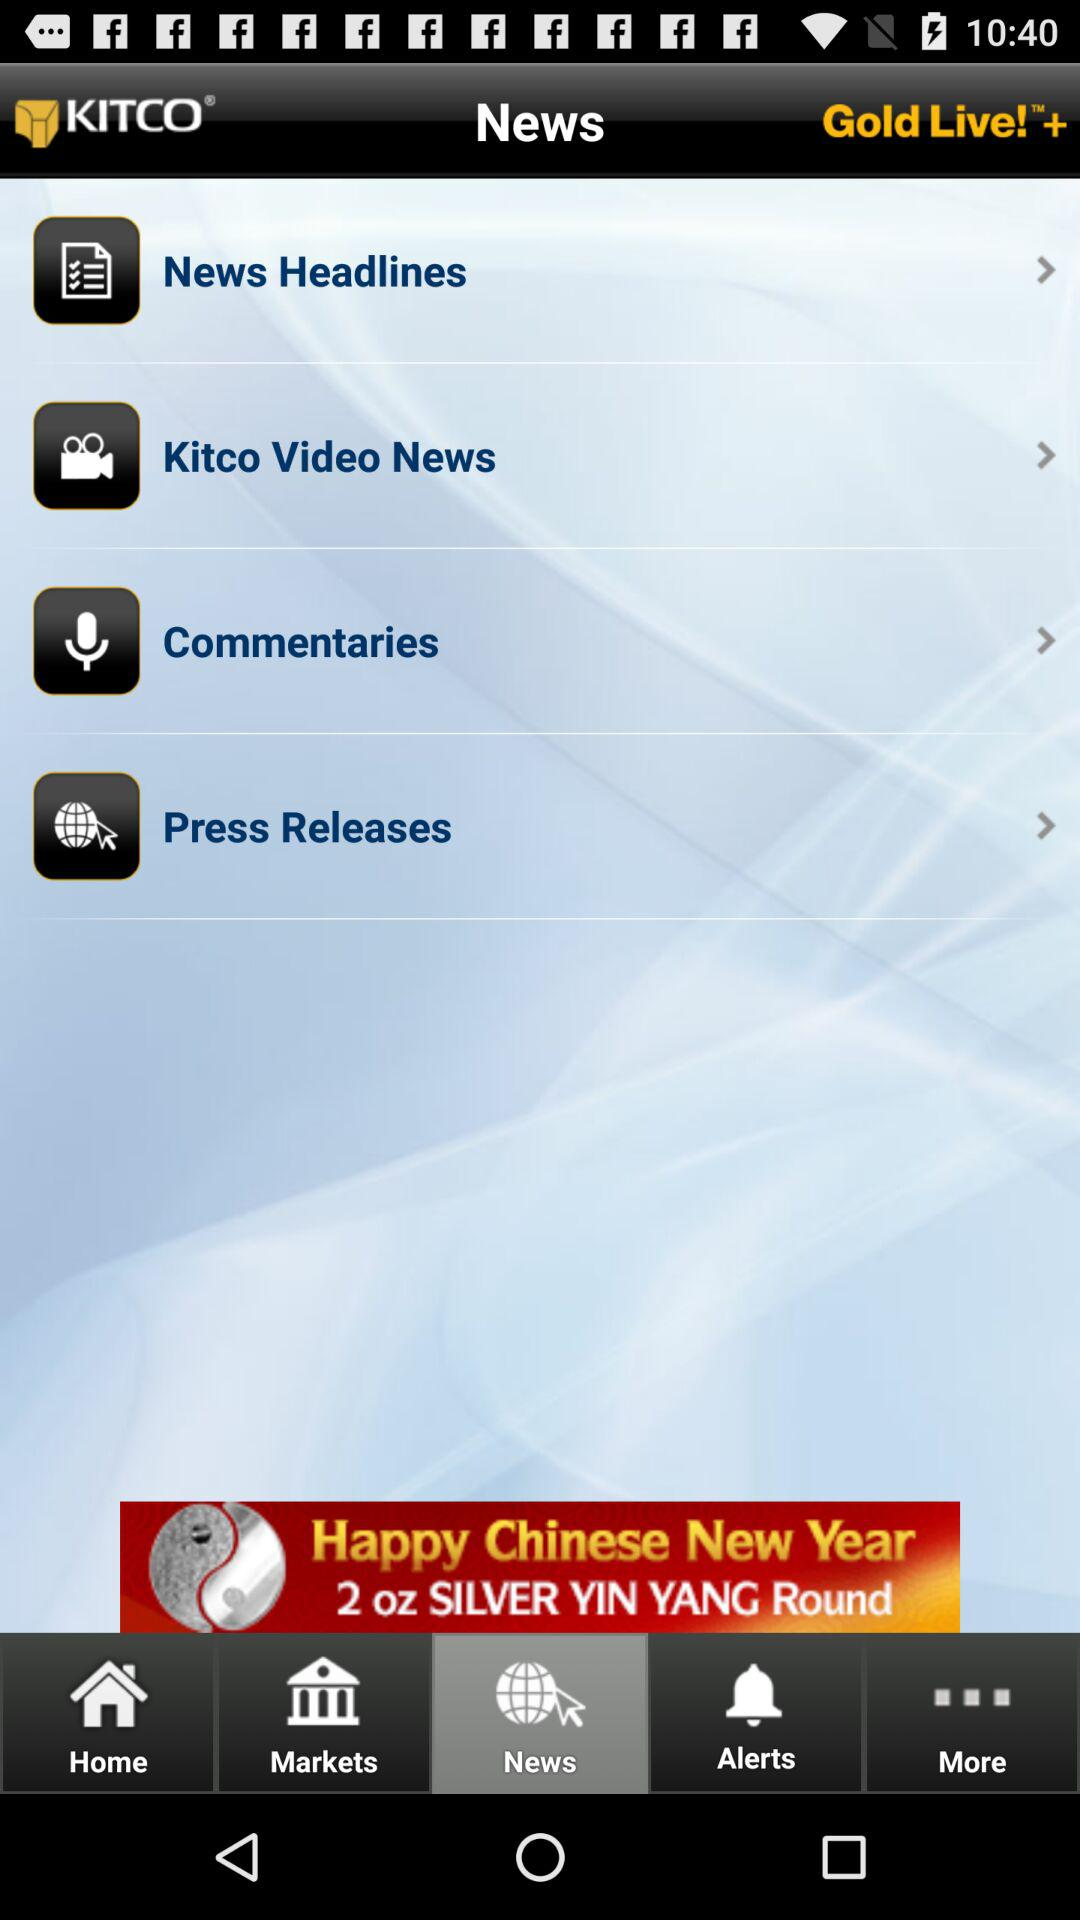Which option is selected? The selected option is "News". 